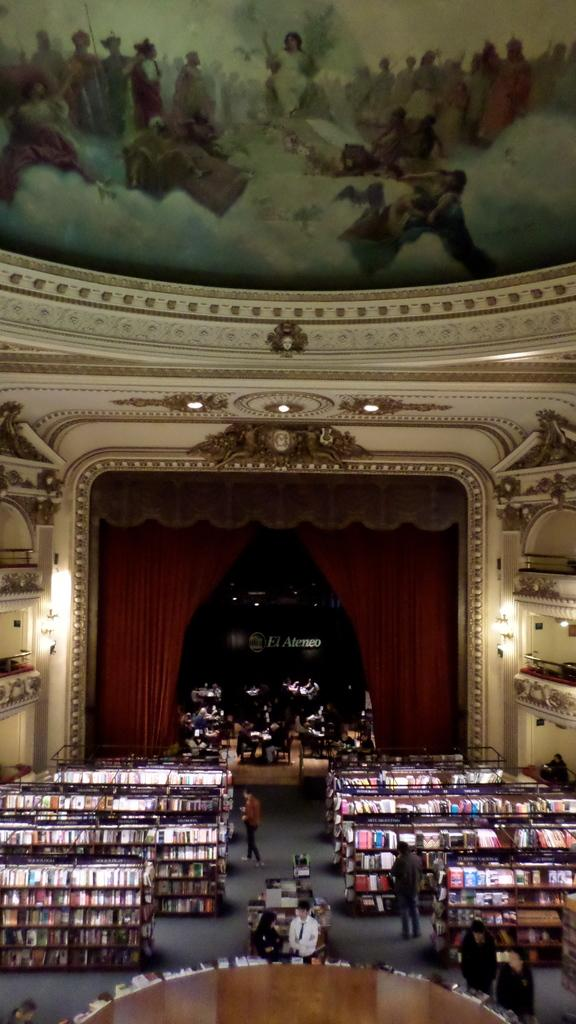What type of place is depicted in the image? The image is of a library. What can be seen at the top of the image? There is a frame at the top of the image. What is located at the bottom of the image? There are bookshelves, books, and people at the bottom of the image. What is in the center of the image? There is a curtain in the center of the image. Can you see a deer or a frog in the image? No, there are no deer or frogs present in the image. Who is the friend that the person in the image is talking to? There is no specific person mentioned in the image, and no friend is visible. 